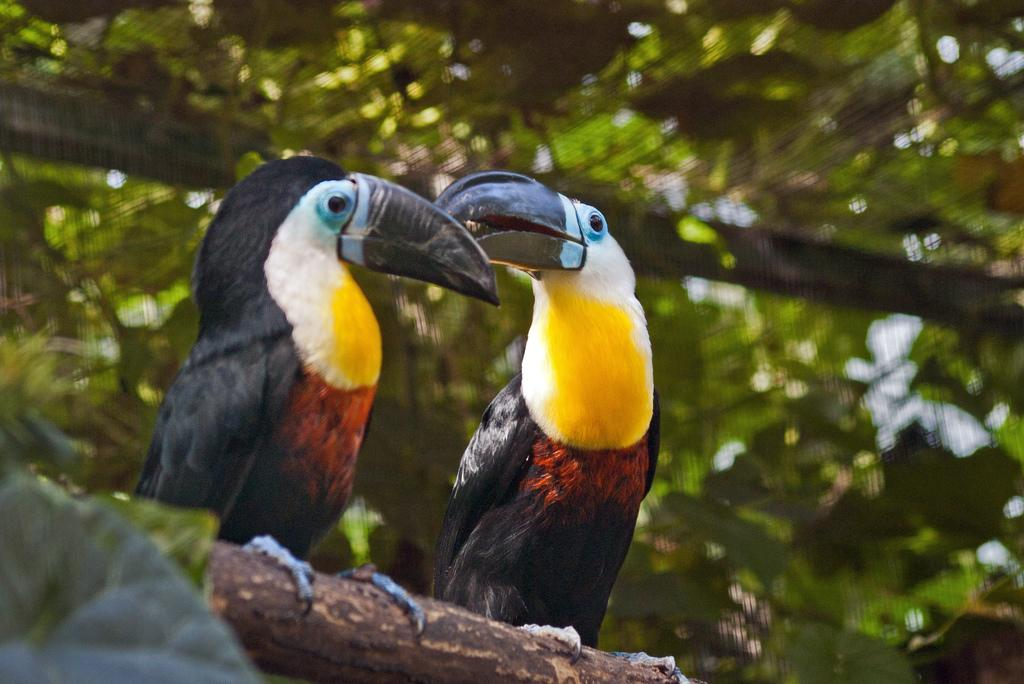How many birds can be seen in the image? There are two birds in the image. Where are the birds located? on the image? What can be seen in the background of the image? There are leaves visible in the background of the image. How are the leaves depicted in the image? The leaves are blurred in the image. What type of design can be seen on the stomach of the beetle in the image? There is no beetle present in the image, so there is no design to be seen on its stomach. 